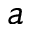<formula> <loc_0><loc_0><loc_500><loc_500>a</formula> 